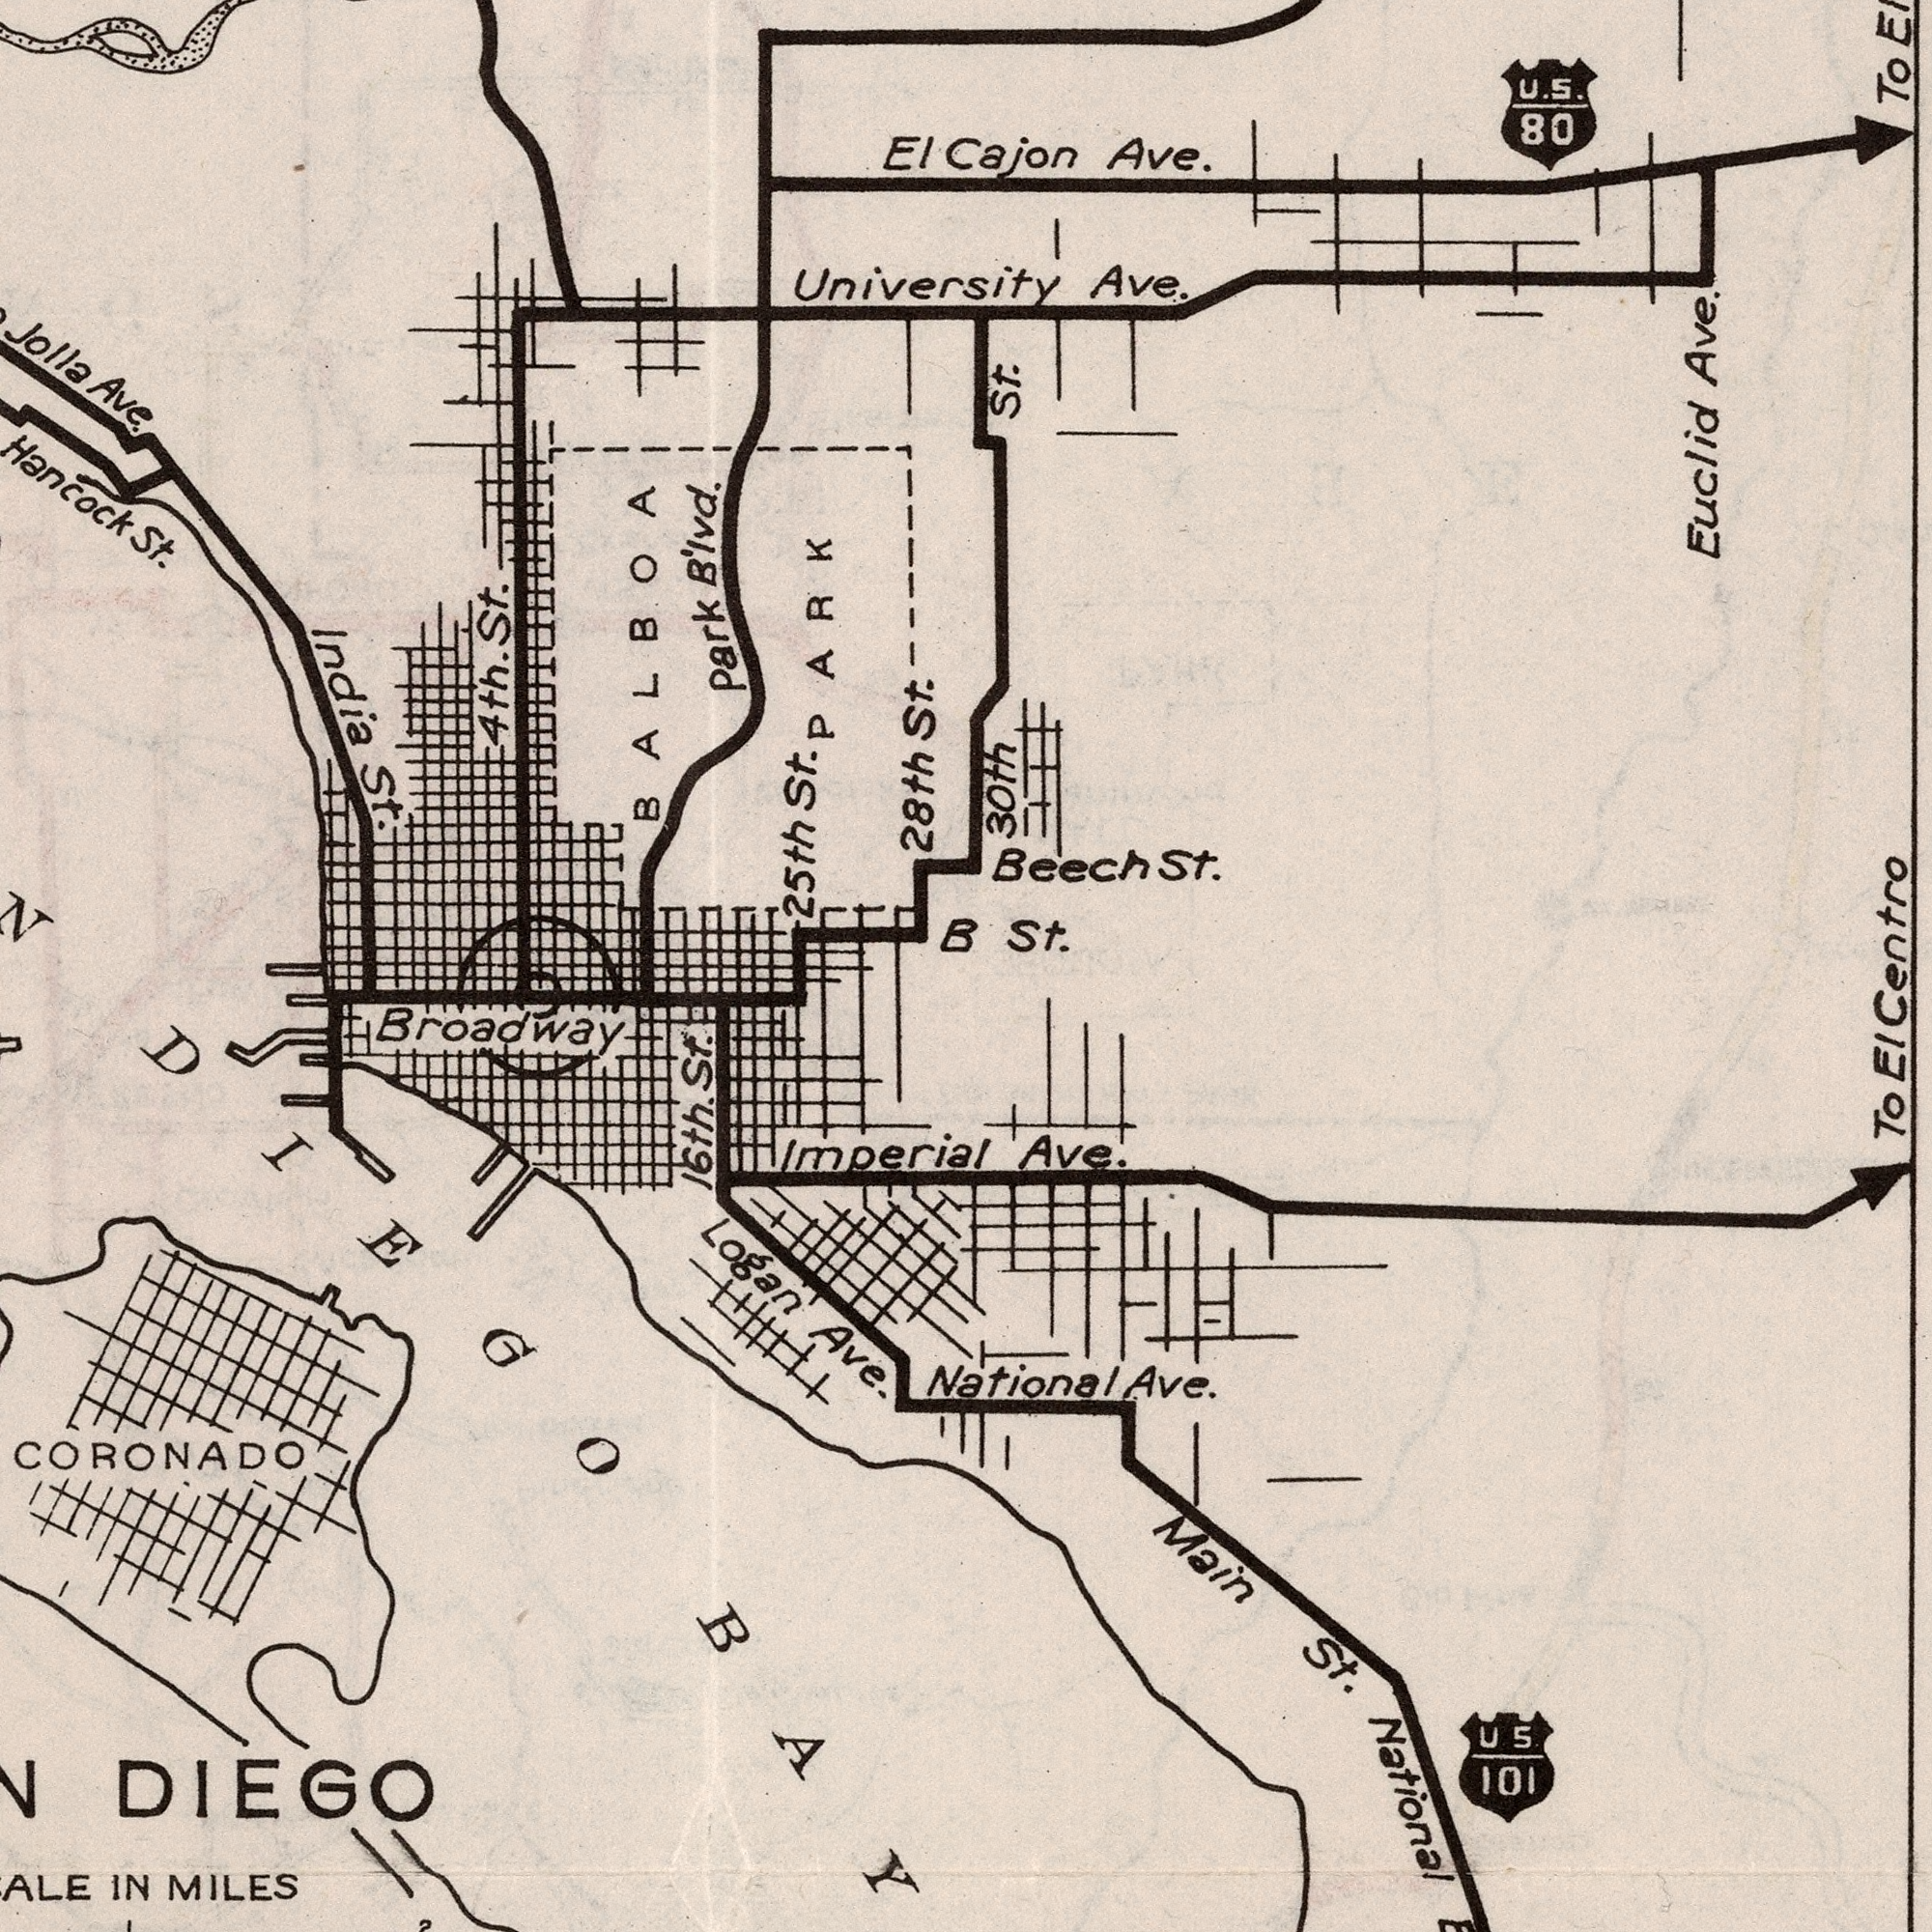What text is visible in the lower-right corner? Ave. Main St. National National Ave. To El U.S. 101 What text is visible in the upper-left corner? 28th St. Hancock St. India St. University 4th. St. Jolla Ave. 25th St. Park B'lvd. El BALBOA B PARK What text can you see in the bottom-left section? Broadway Logan Ave IN MILES 16th. St. Imperial DIEGO CORONADO DIEGO BAY What text can you see in the top-right section? Ave. Cajon Ave. Euclid Ave. Beech St. 30th St. St. U.S. 80 To Centro 